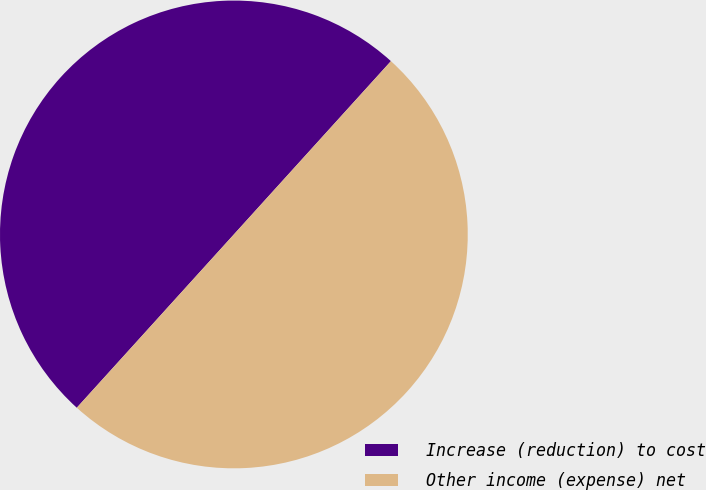Convert chart. <chart><loc_0><loc_0><loc_500><loc_500><pie_chart><fcel>Increase (reduction) to cost<fcel>Other income (expense) net<nl><fcel>50.0%<fcel>50.0%<nl></chart> 